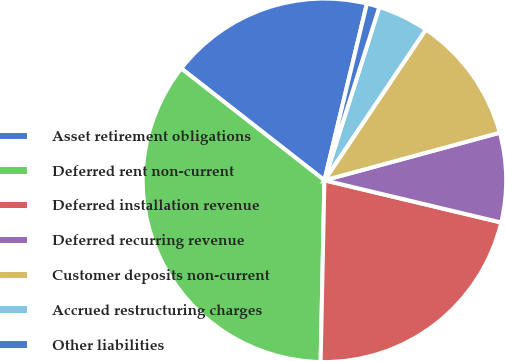Convert chart to OTSL. <chart><loc_0><loc_0><loc_500><loc_500><pie_chart><fcel>Asset retirement obligations<fcel>Deferred rent non-current<fcel>Deferred installation revenue<fcel>Deferred recurring revenue<fcel>Customer deposits non-current<fcel>Accrued restructuring charges<fcel>Other liabilities<nl><fcel>18.2%<fcel>35.23%<fcel>21.61%<fcel>7.95%<fcel>11.36%<fcel>4.54%<fcel>1.13%<nl></chart> 